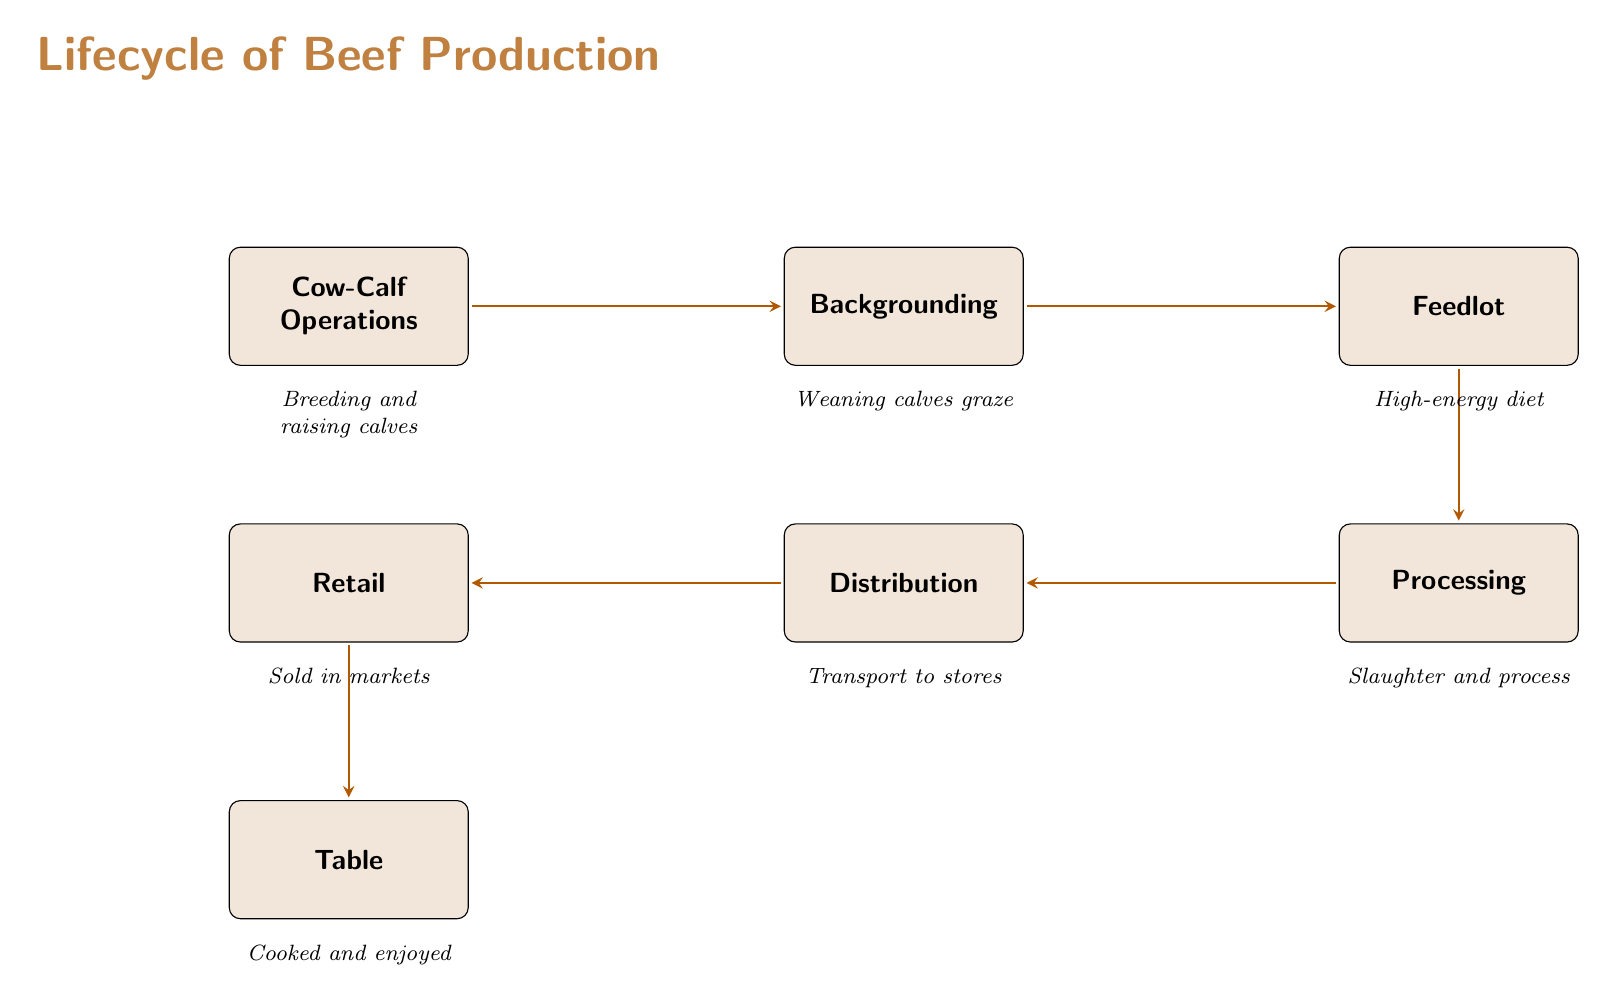What process comes after cow-calf operations? The diagram flows from cow-calf operations to backgrounding, indicating that backgrounding is the next step.
Answer: Backgrounding How many main stages are there in the lifecycle of beef production? By counting the boxes in the diagram, we find a total of six main stages: cow-calf operations, backgrounding, feedlot, processing, distribution, and retail.
Answer: Six What is the final stage before beef is enjoyed? The last stage in the diagram before the beef is enjoyed is the retail stage, which takes place just before it reaches the table.
Answer: Retail What type of diet do cattle have in the feedlot? The diagram specifies that cattle are given a high-energy diet during the feedlot stage of production.
Answer: High-energy diet How do cattle get to market from processing? According to the diagram, after processing, the beef is transported to stores, indicating that distribution is the link between processing and retail.
Answer: Transport to stores What activity occurs during cow-calf operations? The diagram states that cow-calf operations involve breeding and raising calves, making this the activity associated with the first stage.
Answer: Breeding and raising calves What happens immediately after the processing stage? The diagram shows that immediately after processing, the beef is distributed, highlighting the flow from processing to distribution.
Answer: Distribution What stage involves weaning calves? The backgrounding stage is specifically associated with weaning calves, as noted in the description beneath it in the diagram.
Answer: Backgrounding What comes after the feedlot in the lifecycle? Following the feedlot stage in the diagram is the processing stage, indicating that this is the sequence of events in beef production.
Answer: Processing 